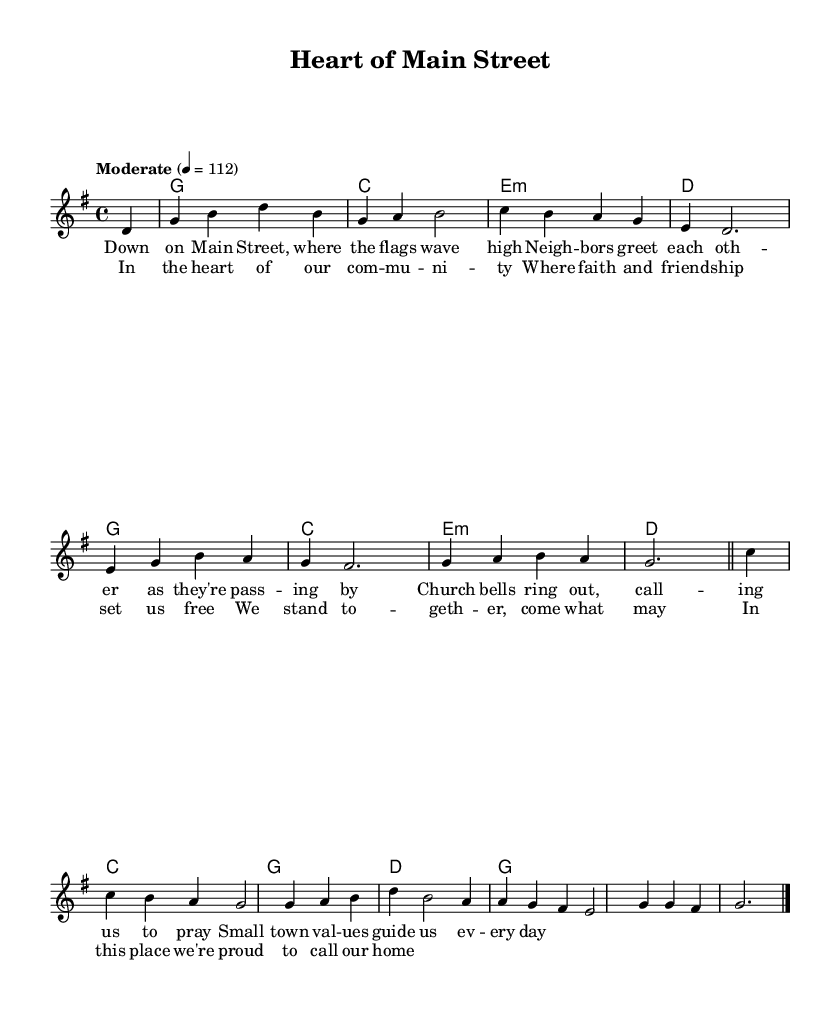What is the key signature of this music? The key signature is G major, which has one sharp (F#). This is indicated at the beginning of the score.
Answer: G major What is the time signature of this music? The time signature is 4/4, which means there are four beats in each measure. This can be seen at the start of the score right after the key signature.
Answer: 4/4 What is the tempo marking for this piece? The tempo marking is "Moderate" at a speed of 112 beats per minute, which indicates the intended pace at which the piece should be played. This is specified in the tempo instruction at the beginning of the score.
Answer: Moderate 112 How many measures are there in the melody? The melody consists of 8 measures, which can be counted by identifying the vertical lines that separate each measure in the sheet music.
Answer: 8 What are the main themes expressed in the lyrics? The lyrics focus on small-town life and community values, particularly illustrating neighborly interactions, the importance of faith, and pride in one’s home. This thematic content is derived from analyzing the lyrics provided under the melody.
Answer: Small-town life and community values Which chords are used in the verse? The chords used in the verse are G, C, E minor, and D. These chords support the melody and can be found written above the corresponding measures of music.
Answer: G, C, E minor, D What is the overall mood conveyed by the combination of lyrics and melody? The overall mood is uplifting and reflective, characterized by a sense of community and shared values, evident from the positive imagery and harmonic structure in the song. This can be inferred by combining the themes in the lyrics with the melodic contour.
Answer: Uplifting and reflective 